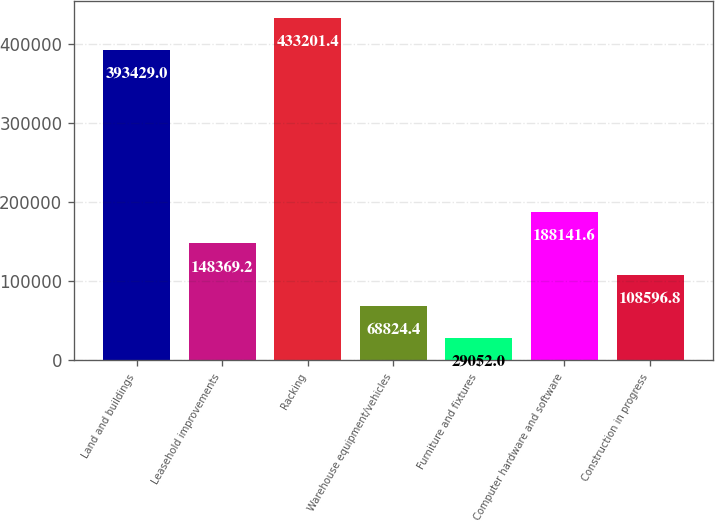Convert chart to OTSL. <chart><loc_0><loc_0><loc_500><loc_500><bar_chart><fcel>Land and buildings<fcel>Leasehold improvements<fcel>Racking<fcel>Warehouse equipment/vehicles<fcel>Furniture and fixtures<fcel>Computer hardware and software<fcel>Construction in progress<nl><fcel>393429<fcel>148369<fcel>433201<fcel>68824.4<fcel>29052<fcel>188142<fcel>108597<nl></chart> 